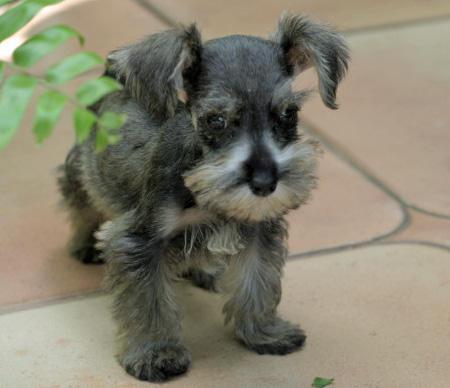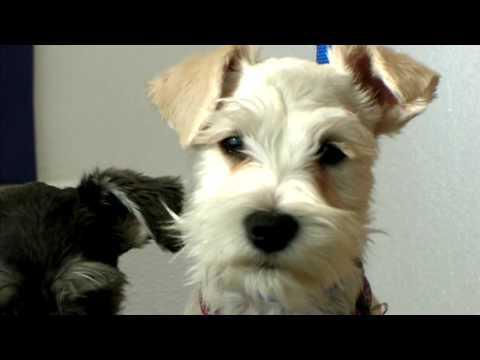The first image is the image on the left, the second image is the image on the right. Assess this claim about the two images: "One of the images contains a dog with only the head showing.". Correct or not? Answer yes or no. Yes. 